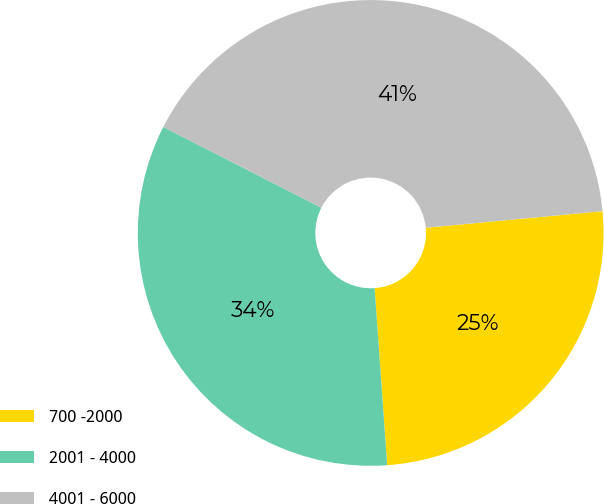<chart> <loc_0><loc_0><loc_500><loc_500><pie_chart><fcel>700 -2000<fcel>2001 - 4000<fcel>4001 - 6000<nl><fcel>25.36%<fcel>33.65%<fcel>40.99%<nl></chart> 